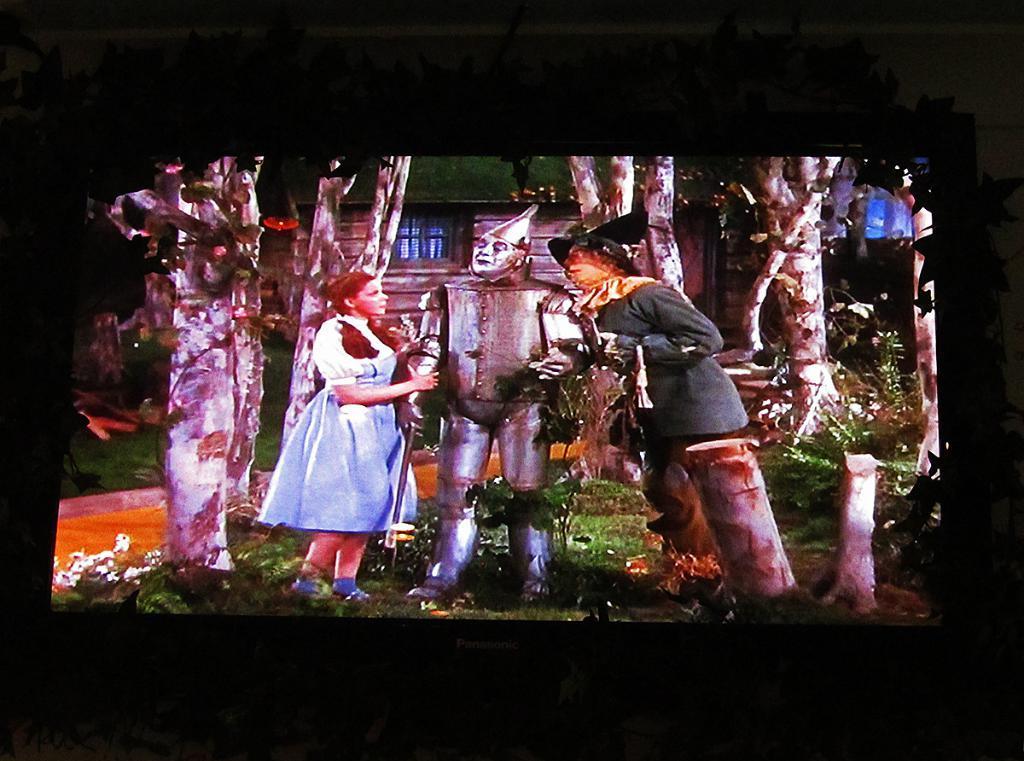Can you describe this image briefly? This image consists of a screen on which I can see two persons, a robot are standing on the ground and in the background there are some trees and a house. 